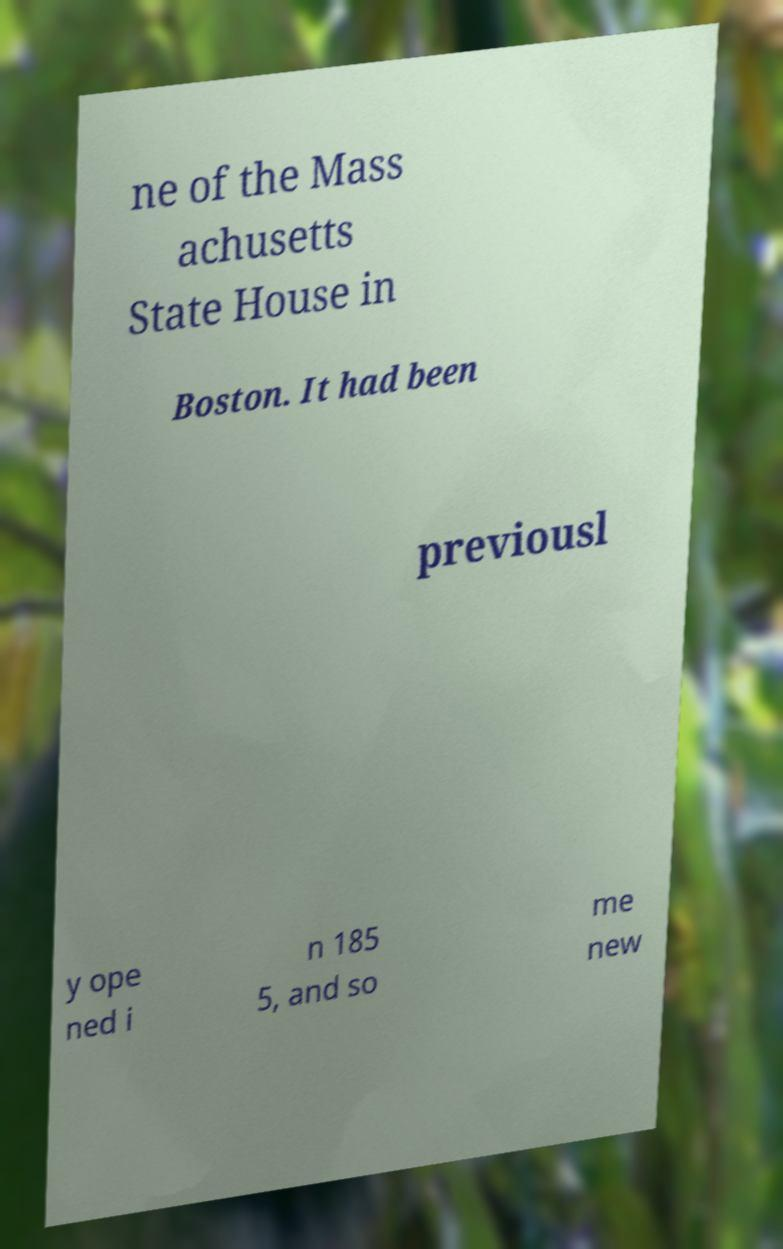For documentation purposes, I need the text within this image transcribed. Could you provide that? ne of the Mass achusetts State House in Boston. It had been previousl y ope ned i n 185 5, and so me new 